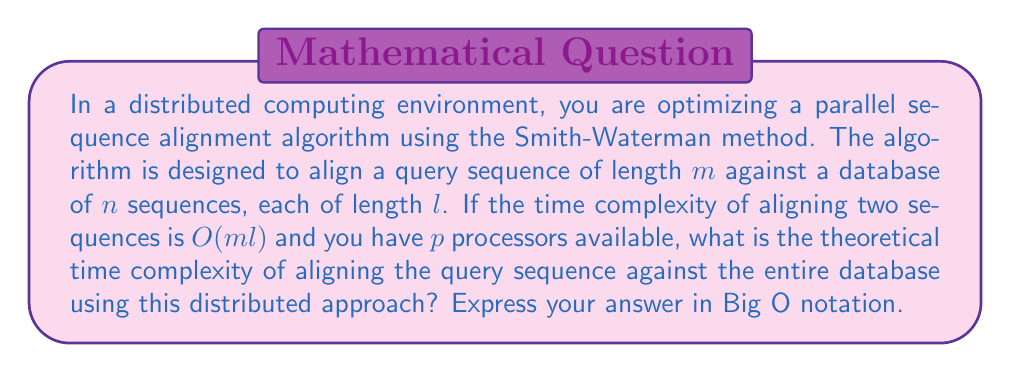What is the answer to this math problem? To solve this problem, let's break it down step by step:

1) First, recall that the Smith-Waterman algorithm for aligning two sequences has a time complexity of $O(ml)$, where $m$ is the length of the query sequence and $l$ is the length of the database sequence.

2) We need to align the query sequence against $n$ database sequences. Without parallelization, this would take $O(nml)$ time.

3) In a distributed computing environment with $p$ processors, we can divide the workload among these processors. Ideally, each processor would handle $\frac{n}{p}$ sequences from the database.

4) The time complexity for each processor would then be:

   $$O(\frac{n}{p} \cdot ml)$$

5) Since all processors are working in parallel, the overall time complexity is determined by the workload of a single processor. We don't multiply by $p$ because the processors are working simultaneously.

6) However, we need to consider that there might be some overhead in distributing the work and collecting the results. This is typically considered to be negligible compared to the main computation, especially for large datasets.

7) Therefore, the theoretical time complexity of the distributed algorithm remains:

   $$O(\frac{nml}{p})$$

This represents a speedup of $p$ compared to the non-distributed version, which is the ideal scenario in parallel computing known as linear speedup.
Answer: $O(\frac{nml}{p})$ 